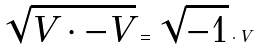<formula> <loc_0><loc_0><loc_500><loc_500>\sqrt { V \cdot - V } = \sqrt { - 1 } \cdot V</formula> 